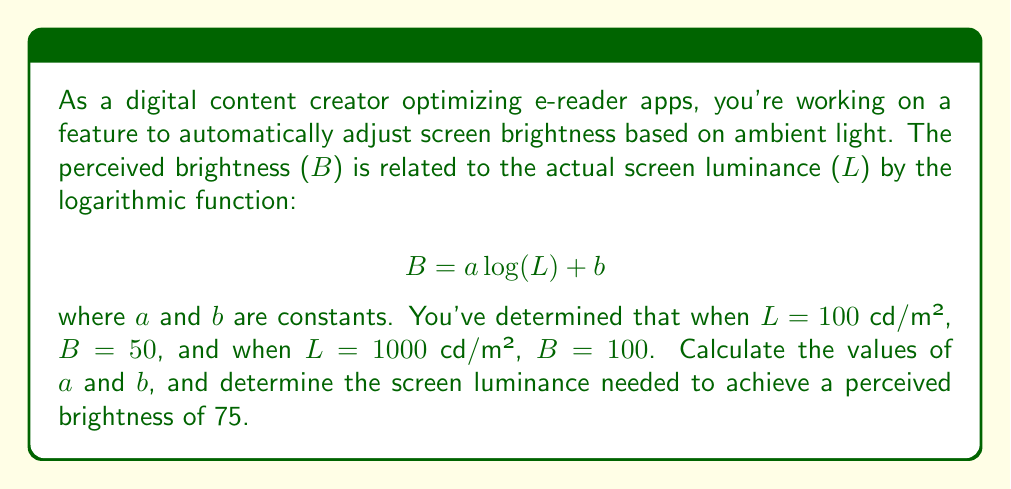Help me with this question. To solve this problem, we'll follow these steps:

1) We have two known points: (100, 50) and (1000, 100). Let's use these to set up two equations:

   50 = a log(100) + b
   100 = a log(1000) + b

2) Simplify the logarithms:
   
   50 = 2a + b
   100 = 3a + b

3) Subtract the first equation from the second:

   50 = a

4) Substitute this back into either of the original equations. Let's use the first one:

   50 = 50 log(100) + b
   50 = 100 + b
   b = -50

5) So our brightness function is:

   $$B = 50 \log(L) - 50$$

6) To find the luminance for a perceived brightness of 75, we solve:

   75 = 50 log(L) - 50
   125 = 50 log(L)
   2.5 = log(L)
   $$L = 10^{2.5} \approx 316.23$$

Therefore, the screen luminance needed for a perceived brightness of 75 is approximately 316.23 cd/m².
Answer: $a = 50$, $b = -50$, and the required luminance is approximately 316.23 cd/m². 